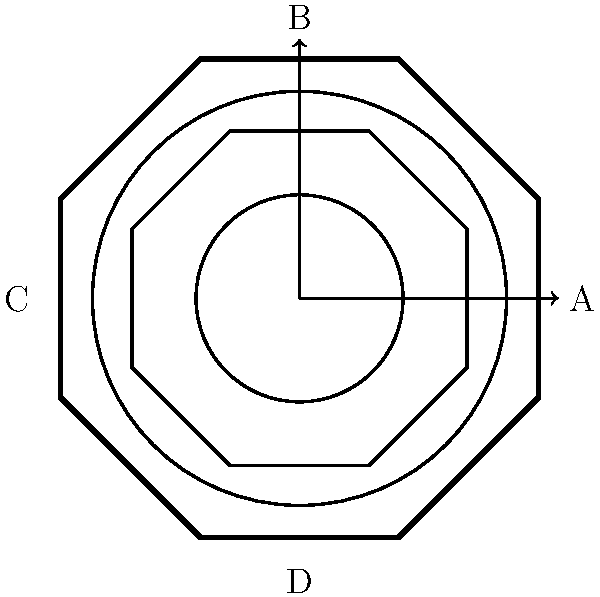In the geometric pattern above, inspired by illuminated manuscript borders from the medieval period, what is the measure of angle BAD? To determine the measure of angle BAD, we need to follow these steps:

1. Recognize that the outer shape is a regular octagon, which has 8 equal sides and 8 equal angles.

2. Recall that the sum of interior angles of an octagon is given by the formula:
   $$(n-2) \times 180°$$
   where $n$ is the number of sides. For an octagon, $n = 8$.

3. Calculate the sum of interior angles:
   $$(8-2) \times 180° = 6 \times 180° = 1080°$$

4. Since the octagon is regular, each interior angle measures:
   $$1080° \div 8 = 135°$$

5. The angle BAD is formed by two radii of the octagon, connecting the center to two adjacent vertices.

6. This angle is supplementary to the interior angle of the octagon. Therefore:
   $$\text{Angle BAD} + 135° = 180°$$

7. Solve for angle BAD:
   $$\text{Angle BAD} = 180° - 135° = 45°$$

Thus, the measure of angle BAD is 45°.
Answer: 45° 